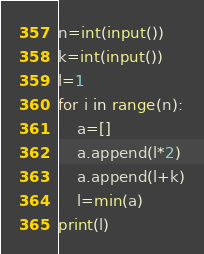Convert code to text. <code><loc_0><loc_0><loc_500><loc_500><_Python_>n=int(input())
k=int(input())
l=1
for i in range(n):
    a=[]
    a.append(l*2)
    a.append(l+k)
    l=min(a)
print(l)

</code> 